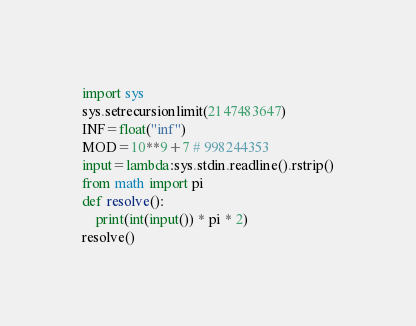<code> <loc_0><loc_0><loc_500><loc_500><_Python_>import sys
sys.setrecursionlimit(2147483647)
INF=float("inf")
MOD=10**9+7 # 998244353
input=lambda:sys.stdin.readline().rstrip()
from math import pi
def resolve():
    print(int(input()) * pi * 2)
resolve()</code> 